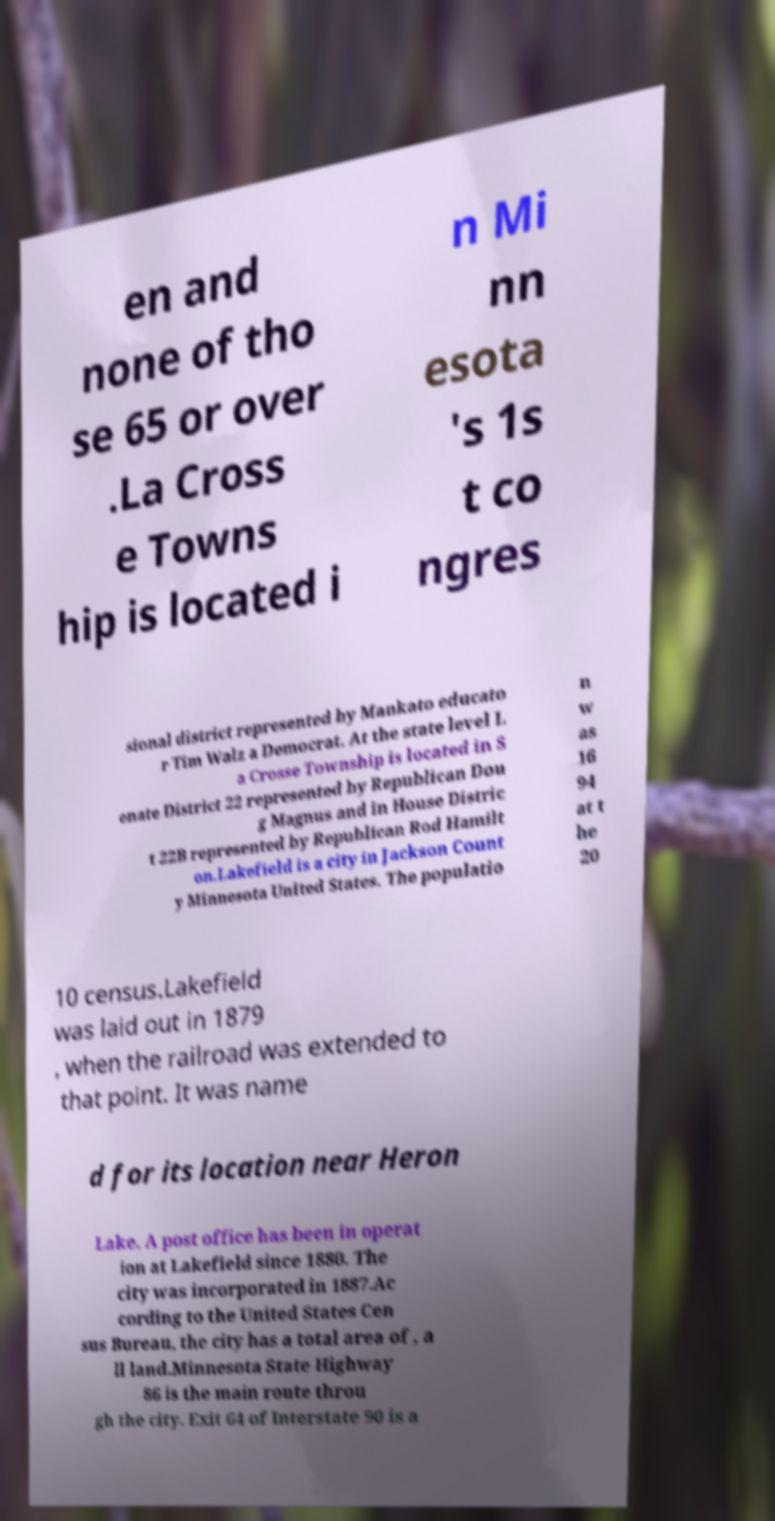What messages or text are displayed in this image? I need them in a readable, typed format. en and none of tho se 65 or over .La Cross e Towns hip is located i n Mi nn esota 's 1s t co ngres sional district represented by Mankato educato r Tim Walz a Democrat. At the state level L a Crosse Township is located in S enate District 22 represented by Republican Dou g Magnus and in House Distric t 22B represented by Republican Rod Hamilt on.Lakefield is a city in Jackson Count y Minnesota United States. The populatio n w as 16 94 at t he 20 10 census.Lakefield was laid out in 1879 , when the railroad was extended to that point. It was name d for its location near Heron Lake. A post office has been in operat ion at Lakefield since 1880. The city was incorporated in 1887.Ac cording to the United States Cen sus Bureau, the city has a total area of , a ll land.Minnesota State Highway 86 is the main route throu gh the city. Exit 64 of Interstate 90 is a 